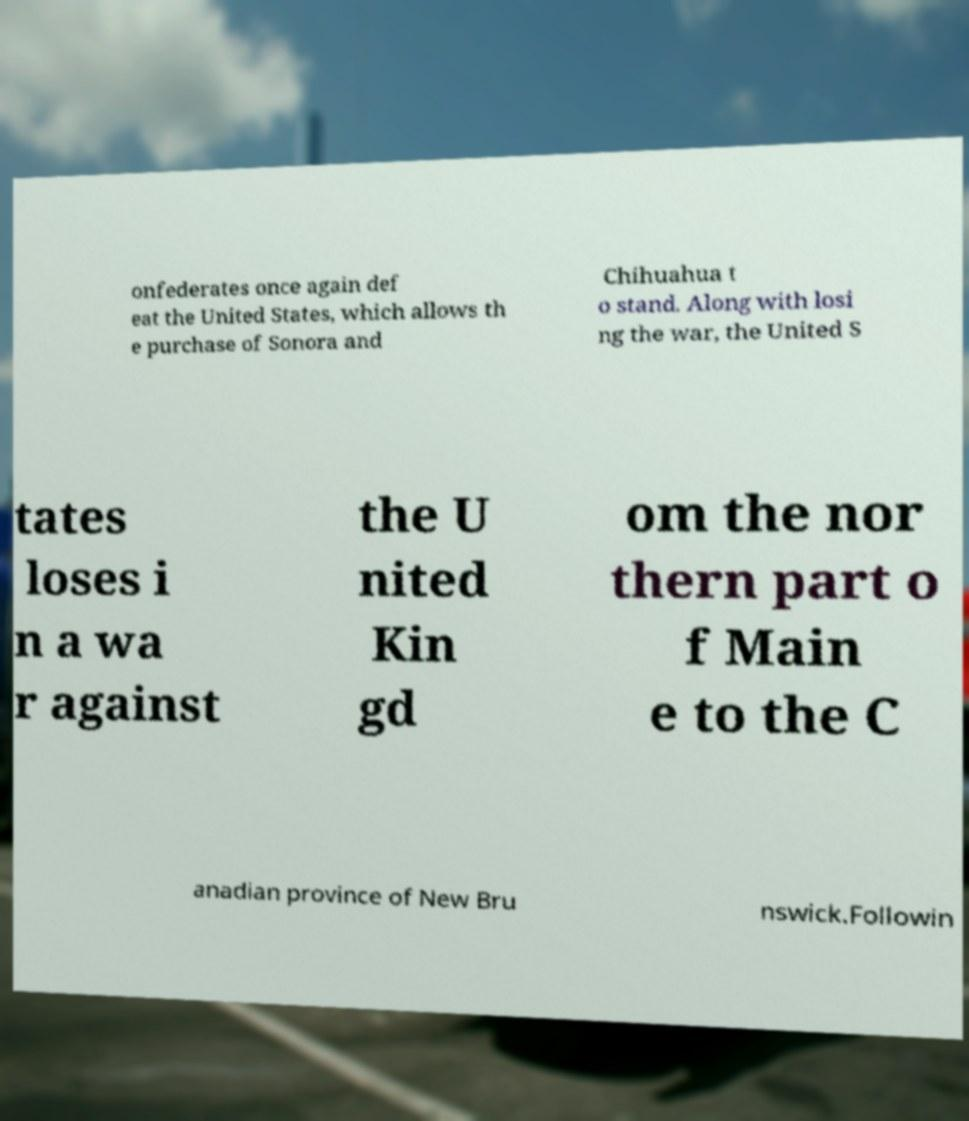Please identify and transcribe the text found in this image. onfederates once again def eat the United States, which allows th e purchase of Sonora and Chihuahua t o stand. Along with losi ng the war, the United S tates loses i n a wa r against the U nited Kin gd om the nor thern part o f Main e to the C anadian province of New Bru nswick.Followin 